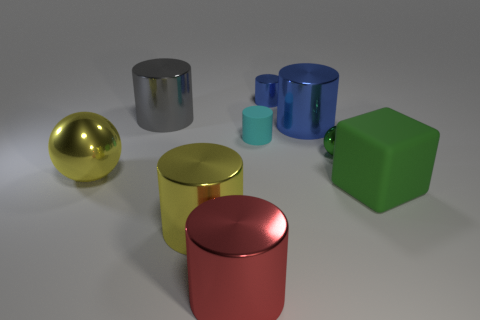There is a rubber thing right of the small green thing; is it the same color as the big metallic thing on the left side of the gray object?
Offer a terse response. No. There is a shiny object that is both to the left of the large yellow metal cylinder and to the right of the yellow ball; what color is it?
Keep it short and to the point. Gray. Is the material of the big blue cylinder the same as the large gray object?
Keep it short and to the point. Yes. What number of tiny objects are either green matte cubes or blue things?
Offer a terse response. 1. Is there anything else that is the same shape as the big gray metal object?
Provide a short and direct response. Yes. Is there any other thing that is the same size as the cyan cylinder?
Your answer should be very brief. Yes. The block that is made of the same material as the cyan cylinder is what color?
Provide a succinct answer. Green. What color is the rubber thing that is left of the large block?
Offer a terse response. Cyan. How many small metal balls are the same color as the matte cylinder?
Offer a very short reply. 0. Are there fewer large green matte things that are on the left side of the cyan object than large red things to the right of the small green metal object?
Your answer should be very brief. No. 